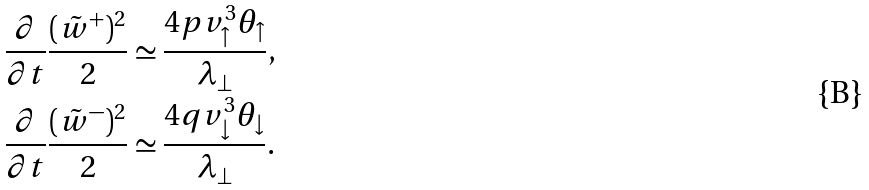<formula> <loc_0><loc_0><loc_500><loc_500>\frac { \partial } { \partial t } \frac { ( \tilde { w } ^ { + } ) ^ { 2 } } { 2 } & \simeq \frac { 4 p v _ { \uparrow } ^ { 3 } \theta _ { \uparrow } } { \lambda _ { \perp } } , \\ \frac { \partial } { \partial t } \frac { ( \tilde { w } ^ { - } ) ^ { 2 } } { 2 } & \simeq \frac { 4 q v _ { \downarrow } ^ { 3 } \theta _ { \downarrow } } { \lambda _ { \perp } } .</formula> 